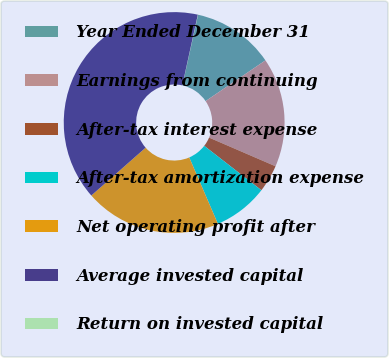<chart> <loc_0><loc_0><loc_500><loc_500><pie_chart><fcel>Year Ended December 31<fcel>Earnings from continuing<fcel>After-tax interest expense<fcel>After-tax amortization expense<fcel>Net operating profit after<fcel>Average invested capital<fcel>Return on invested capital<nl><fcel>12.01%<fcel>16.0%<fcel>4.02%<fcel>8.01%<fcel>19.99%<fcel>39.94%<fcel>0.03%<nl></chart> 